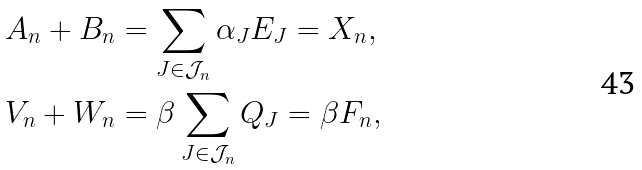Convert formula to latex. <formula><loc_0><loc_0><loc_500><loc_500>A _ { n } + B _ { n } & = \sum _ { J \in \mathcal { J } _ { n } } \alpha _ { J } E _ { J } = X _ { n } , \\ V _ { n } + W _ { n } & = \beta \sum _ { J \in \mathcal { J } _ { n } } Q _ { J } = \beta F _ { n } ,</formula> 